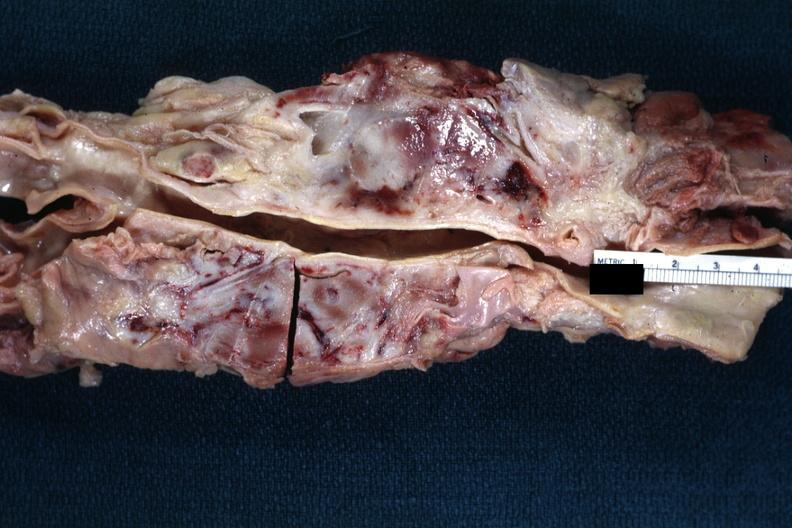what does this image show?
Answer the question using a single word or phrase. Matted and fused periaortic nodes with hemorrhagic necrosis good example 